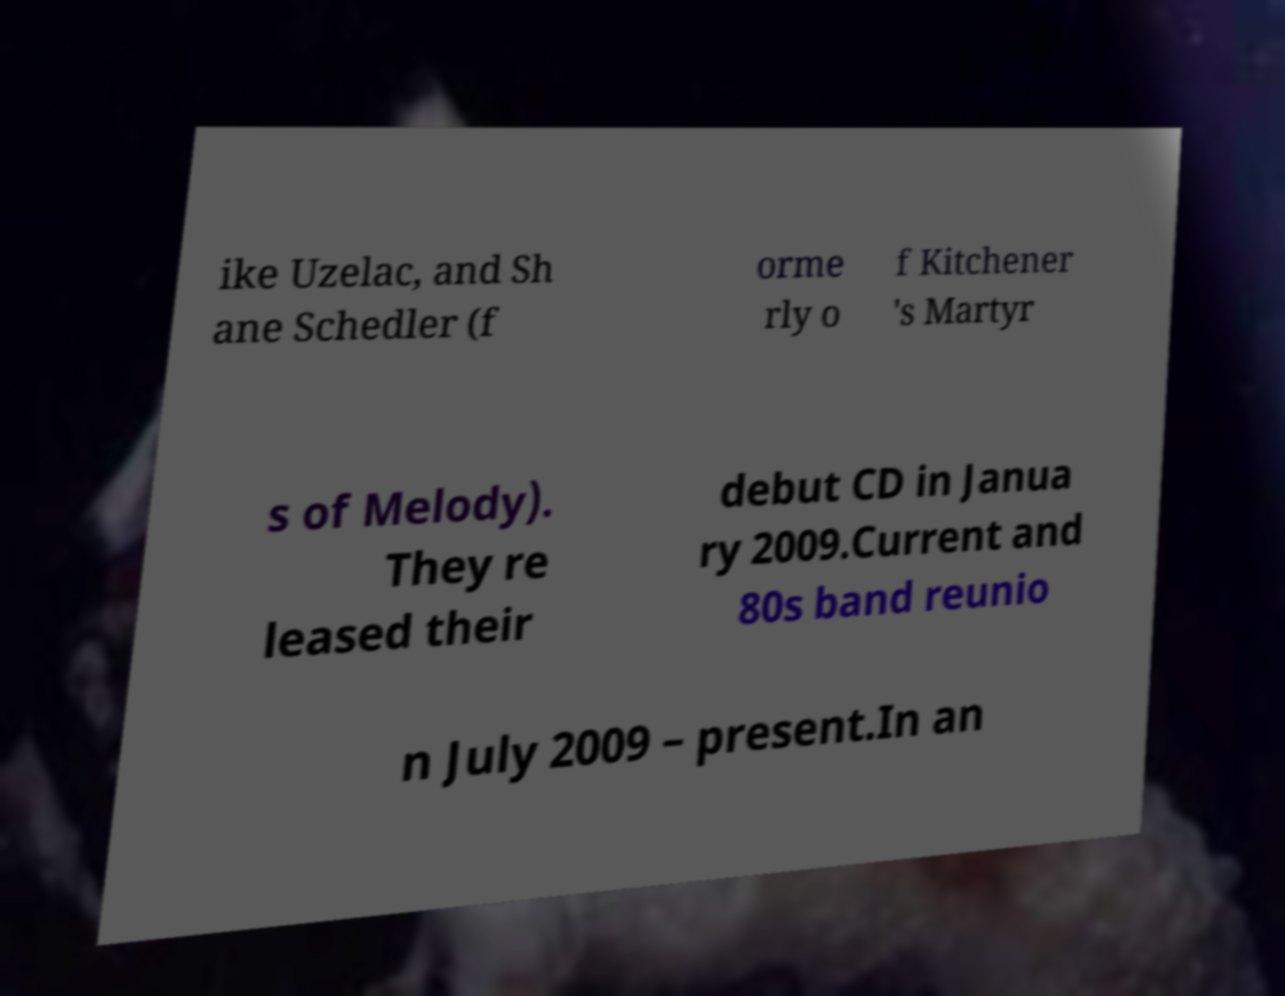Please read and relay the text visible in this image. What does it say? ike Uzelac, and Sh ane Schedler (f orme rly o f Kitchener 's Martyr s of Melody). They re leased their debut CD in Janua ry 2009.Current and 80s band reunio n July 2009 – present.In an 